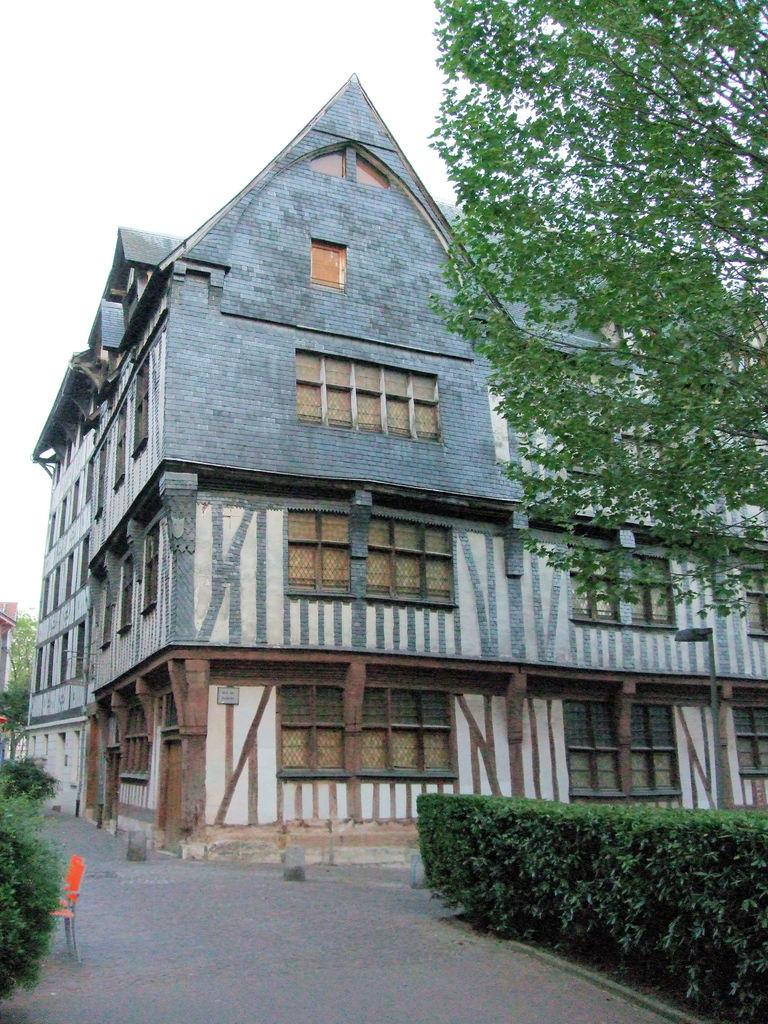What type of structure is present in the image? There is a building in the image. What feature can be seen on the building? There are windows visible in the image. What type of natural elements are present in the image? There are trees in the image. What type of furniture is present in the image? There is an orange color chair in the image. What is the color of the sky in the image? The sky appears to be white in color. Can you hear the voice of the sea in the image? There is no sea or any sound mentioned in the image, so it is not possible to hear the voice of the sea. 